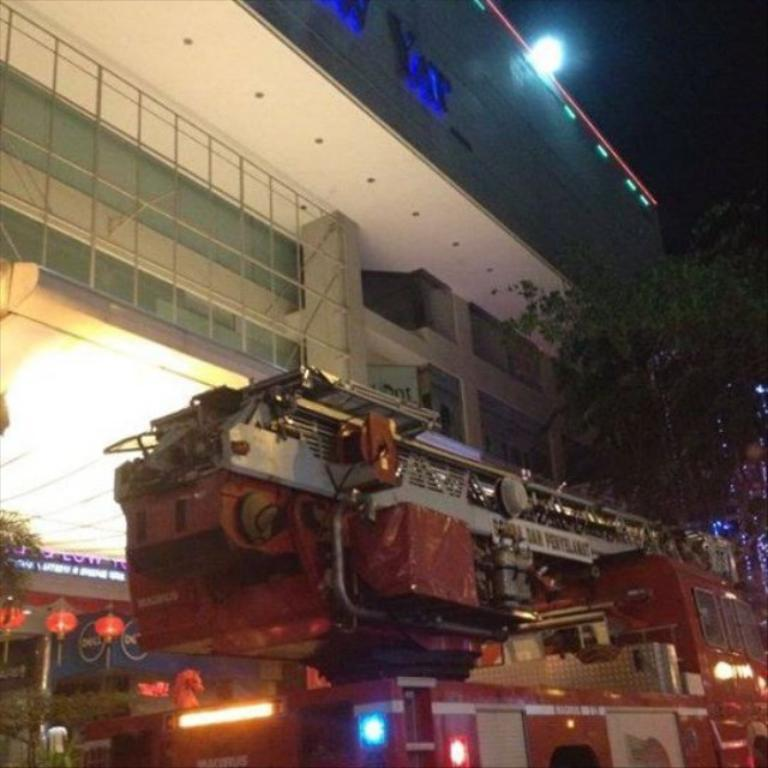What safety device can be seen on the ground in the image? There is a fire extinguisher on the ground in the image. What type of natural environment is visible in the background of the image? There are trees visible in the background of the image. What type of man-made structure is visible in the background of the image? There is a building in the background of the image. What type of force is being applied to the vein in the image? There is no force or vein present in the image. 